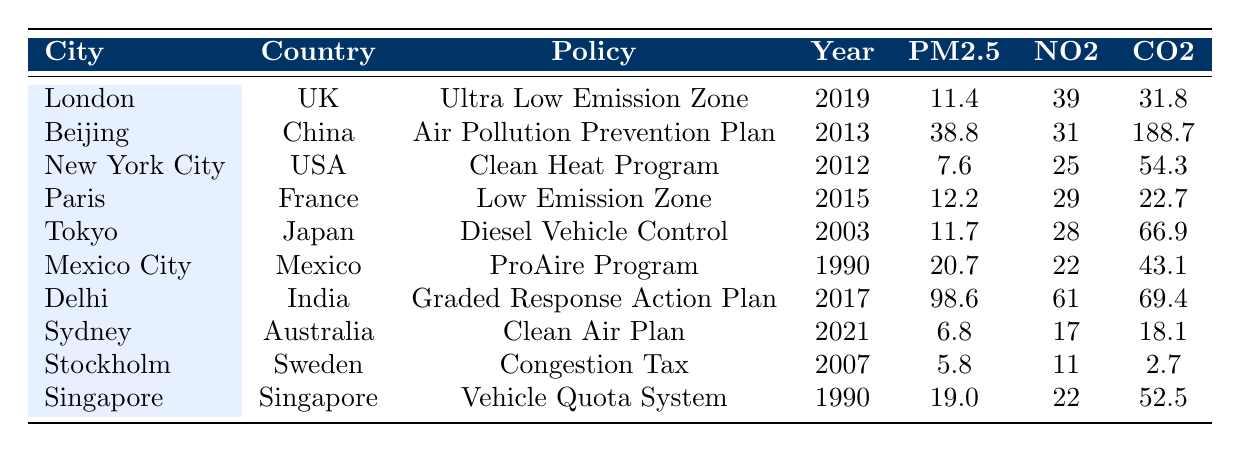What is the PM2.5 level in Delhi? The table lists Delhi with a PM2.5 level of 98.6.
Answer: 98.6 Which city has the lowest NO2 level? By reviewing the NO2 levels in the table, Stockholm has the lowest level at 11.
Answer: 11 Did New York City implement its policy before 2015? Yes, according to the table, New York City's policy was implemented in 2012, which is before 2015.
Answer: Yes How does the CO2 emissions of Beijing compare to the average CO2 emissions of the other cities? Beijing has CO2 emissions of 188.7. The average of the other cities is calculated as (31.8 + 54.3 + 22.7 + 66.9 + 43.1 + 69.4 + 18.1 + 2.7 + 52.5) / 9 = 45.3. Since 188.7 > 45.3, Beijing emits significantly more CO2.
Answer: Higher than average What is the difference in PM2.5 levels between London and Sydney? London has a PM2.5 level of 11.4 and Sydney has a level of 6.8. The difference is 11.4 - 6.8 = 4.6.
Answer: 4.6 Which European city has the most effective policy regarding air quality based on PM2.5 levels? The table shows that Stockholm has the lowest PM2.5 level (5.8) among European cities listed (London, Paris, and Stockholm). This indicates the effectiveness of its policy (Congestion Tax).
Answer: Stockholm What is the relationship between the year a policy was implemented and its effect on CO2 emissions? To analyze this, we check if newer policies correlate with lower CO2 levels. Sydney (2021) has lower emissions than Delhi (2017) but higher than London (2019). Thus, a clear trend cannot be established confidently without more data.
Answer: Inconclusive Is there a city where both PM2.5 and NO2 levels are below the average of the table? First, we calculate the average PM2.5 (23.5) and NO2 levels (31.1). Stockholm has PM2.5 of 5.8 and NO2 of 11, which are below the averages. Therefore, Stockholm meets this criterion.
Answer: Yes, Stockholm What is the total population of the cities that implemented their policies after 2015? The cities with policies implemented after 2015 are Sydney (5,312,163) and Delhi (30,290,936). The total population is 5,312,163 + 30,290,936 = 35,603,099.
Answer: 35,603,099 Which city has the highest CO2 emissions, and what is its value? The table shows Beijing with CO2 emissions of 188.7, which is the highest among all cities listed.
Answer: 188.7 Can we conclude that implementing environmental policies always decreases air pollutants? Based on Delhi's case with high PM2.5 (98.6) despite implementing a policy in 2017, we see that not all policies guarantee reduced air pollutants, indicating a need for more nuanced analysis.
Answer: No, not always 